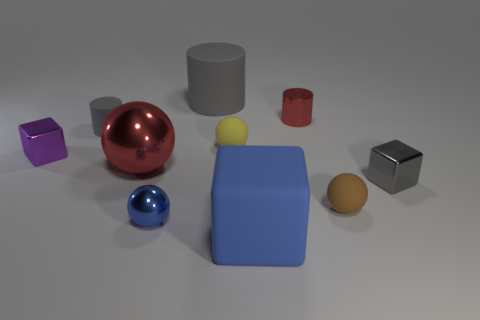Is the color of the big matte object that is behind the big blue rubber object the same as the block that is on the right side of the brown rubber object?
Give a very brief answer. Yes. There is a shiny object that is the same color as the large metallic sphere; what shape is it?
Ensure brevity in your answer.  Cylinder. Do the matte ball that is behind the tiny gray shiny block and the red thing to the right of the blue metallic thing have the same size?
Offer a terse response. Yes. How many objects are either large purple shiny things or matte objects in front of the yellow rubber ball?
Make the answer very short. 2. What size is the metallic cube that is right of the small brown matte ball?
Make the answer very short. Small. Are there fewer tiny gray objects that are left of the big gray cylinder than matte spheres on the left side of the big blue thing?
Ensure brevity in your answer.  No. What is the tiny thing that is on the left side of the big cylinder and in front of the purple object made of?
Provide a short and direct response. Metal. The red thing left of the rubber ball on the left side of the blue rubber cube is what shape?
Provide a short and direct response. Sphere. Is the big block the same color as the big matte cylinder?
Keep it short and to the point. No. How many gray things are metallic balls or big cylinders?
Offer a very short reply. 1. 